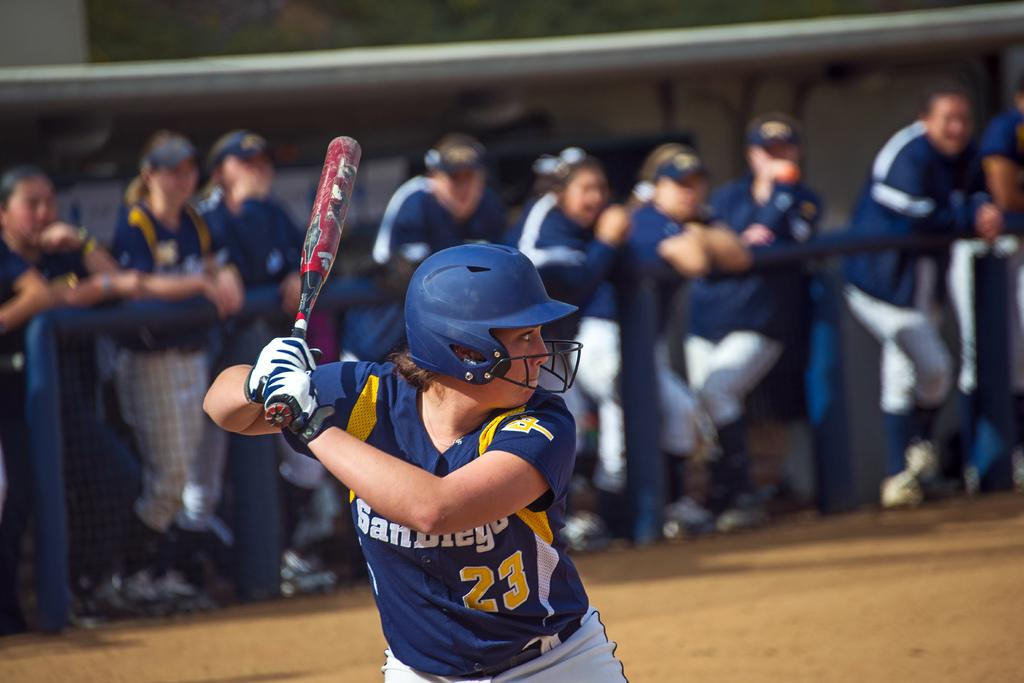<image>
Share a concise interpretation of the image provided. Baseball player with the word San Diego on her chest about to bat. 